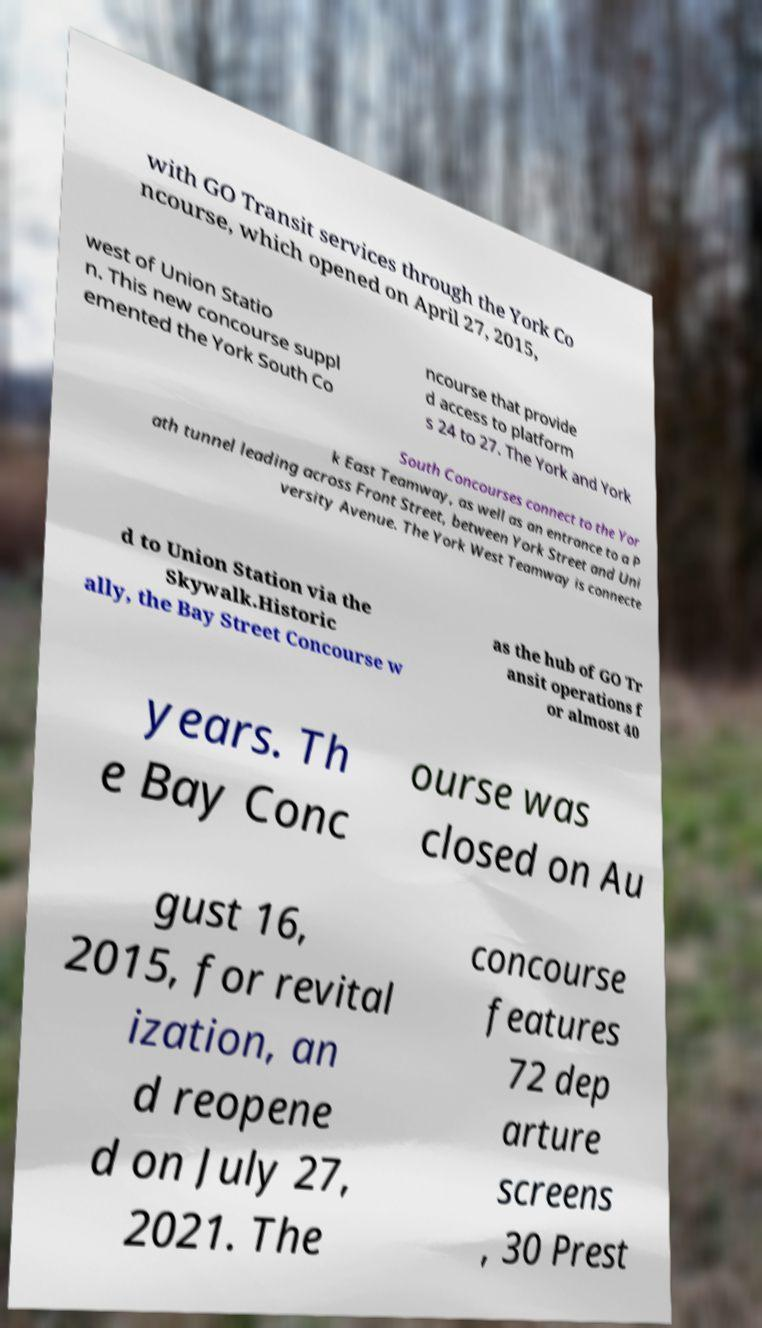Can you read and provide the text displayed in the image?This photo seems to have some interesting text. Can you extract and type it out for me? with GO Transit services through the York Co ncourse, which opened on April 27, 2015, west of Union Statio n. This new concourse suppl emented the York South Co ncourse that provide d access to platform s 24 to 27. The York and York South Concourses connect to the Yor k East Teamway, as well as an entrance to a P ath tunnel leading across Front Street, between York Street and Uni versity Avenue. The York West Teamway is connecte d to Union Station via the Skywalk.Historic ally, the Bay Street Concourse w as the hub of GO Tr ansit operations f or almost 40 years. Th e Bay Conc ourse was closed on Au gust 16, 2015, for revital ization, an d reopene d on July 27, 2021. The concourse features 72 dep arture screens , 30 Prest 